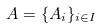<formula> <loc_0><loc_0><loc_500><loc_500>A = \{ A _ { i } \} _ { i \in I }</formula> 